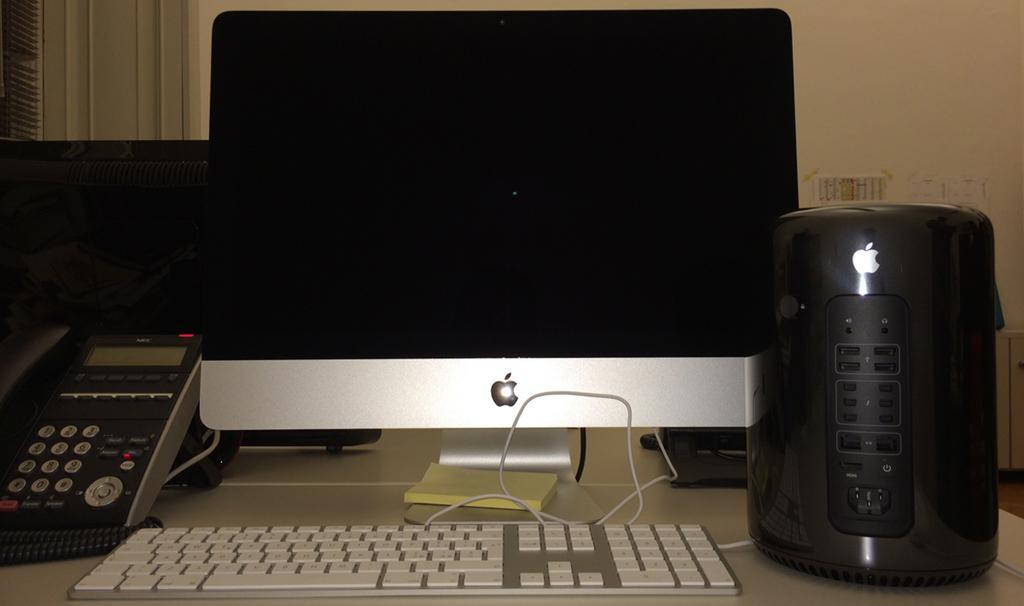Could you give a brief overview of what you see in this image? On this table there is a telephone, notepad, monitor, keyboard and electric machine. 